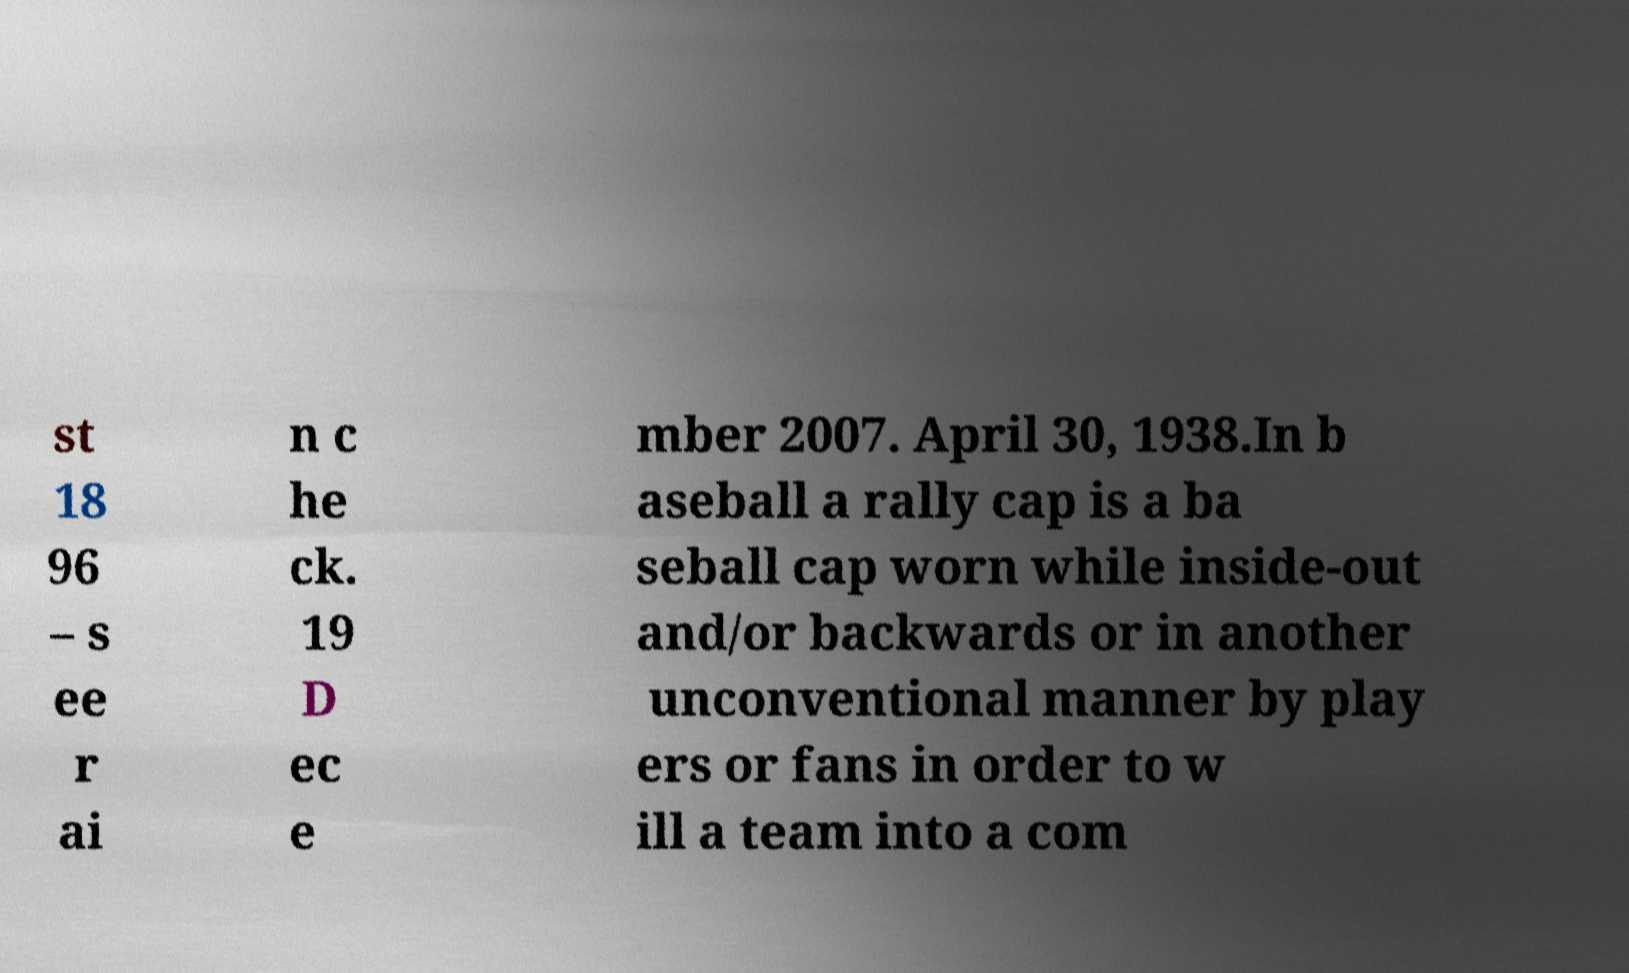I need the written content from this picture converted into text. Can you do that? st 18 96 – s ee r ai n c he ck. 19 D ec e mber 2007. April 30, 1938.In b aseball a rally cap is a ba seball cap worn while inside-out and/or backwards or in another unconventional manner by play ers or fans in order to w ill a team into a com 